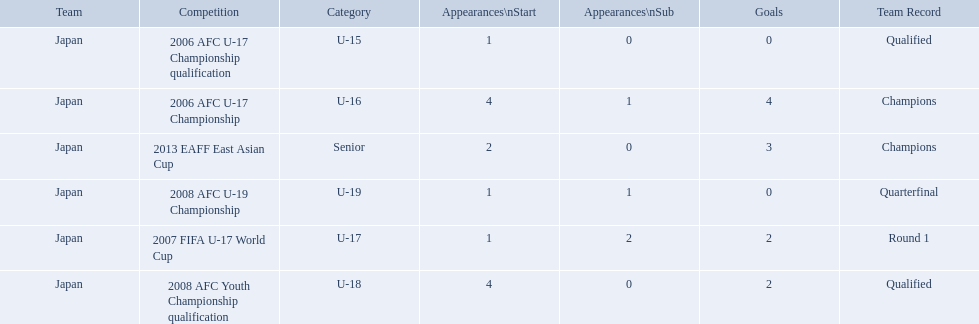What was the team record in 2006? Round 1. What competition did this belong too? 2006 AFC U-17 Championship. 